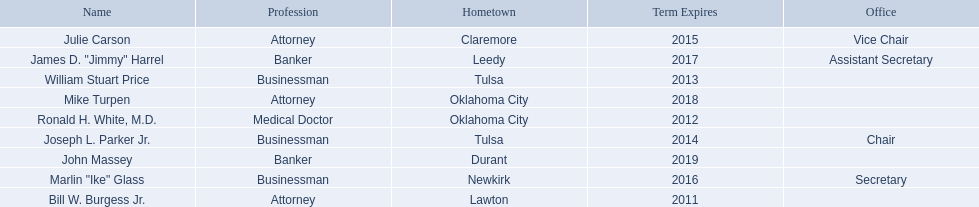What are all of the names? Bill W. Burgess Jr., Ronald H. White, M.D., William Stuart Price, Joseph L. Parker Jr., Julie Carson, Marlin "Ike" Glass, James D. "Jimmy" Harrel, Mike Turpen, John Massey. Where is each member from? Lawton, Oklahoma City, Tulsa, Tulsa, Claremore, Newkirk, Leedy, Oklahoma City, Durant. Along with joseph l. parker jr., which other member is from tulsa? William Stuart Price. 